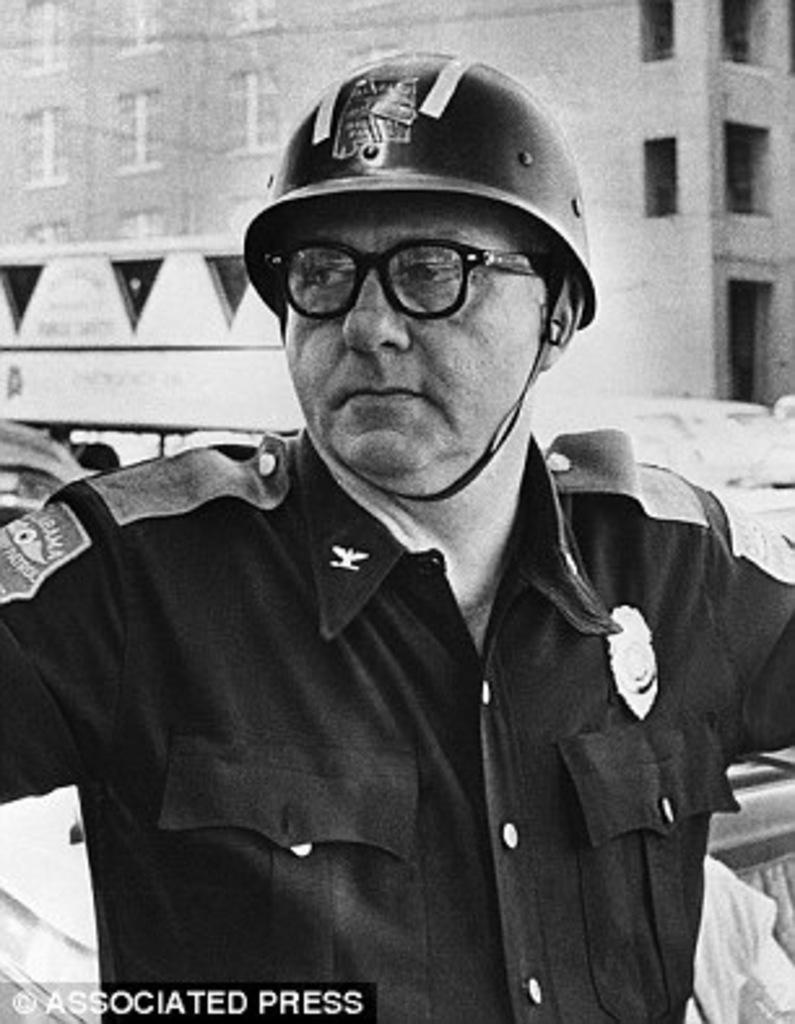In one or two sentences, can you explain what this image depicts? This is a black and white image. In this image we can see a man wearing specs and helmet. In the background we can see a building. At the bottom there is text on the image. 